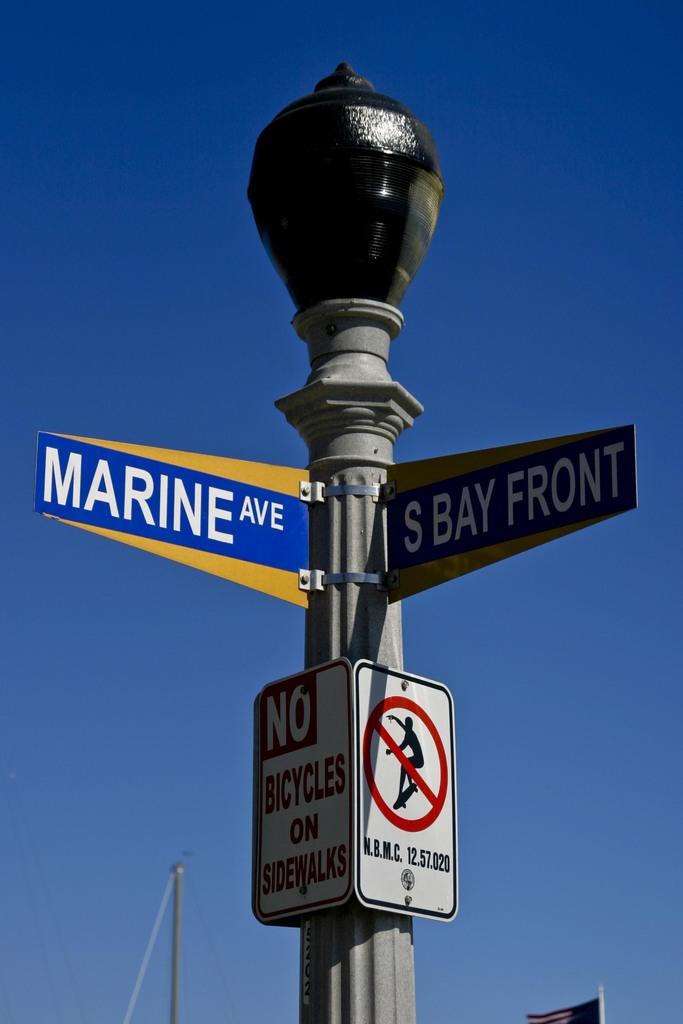Does that sign say no surfing?
Offer a terse response. No. What road is to the right?
Ensure brevity in your answer.  S bay front. 